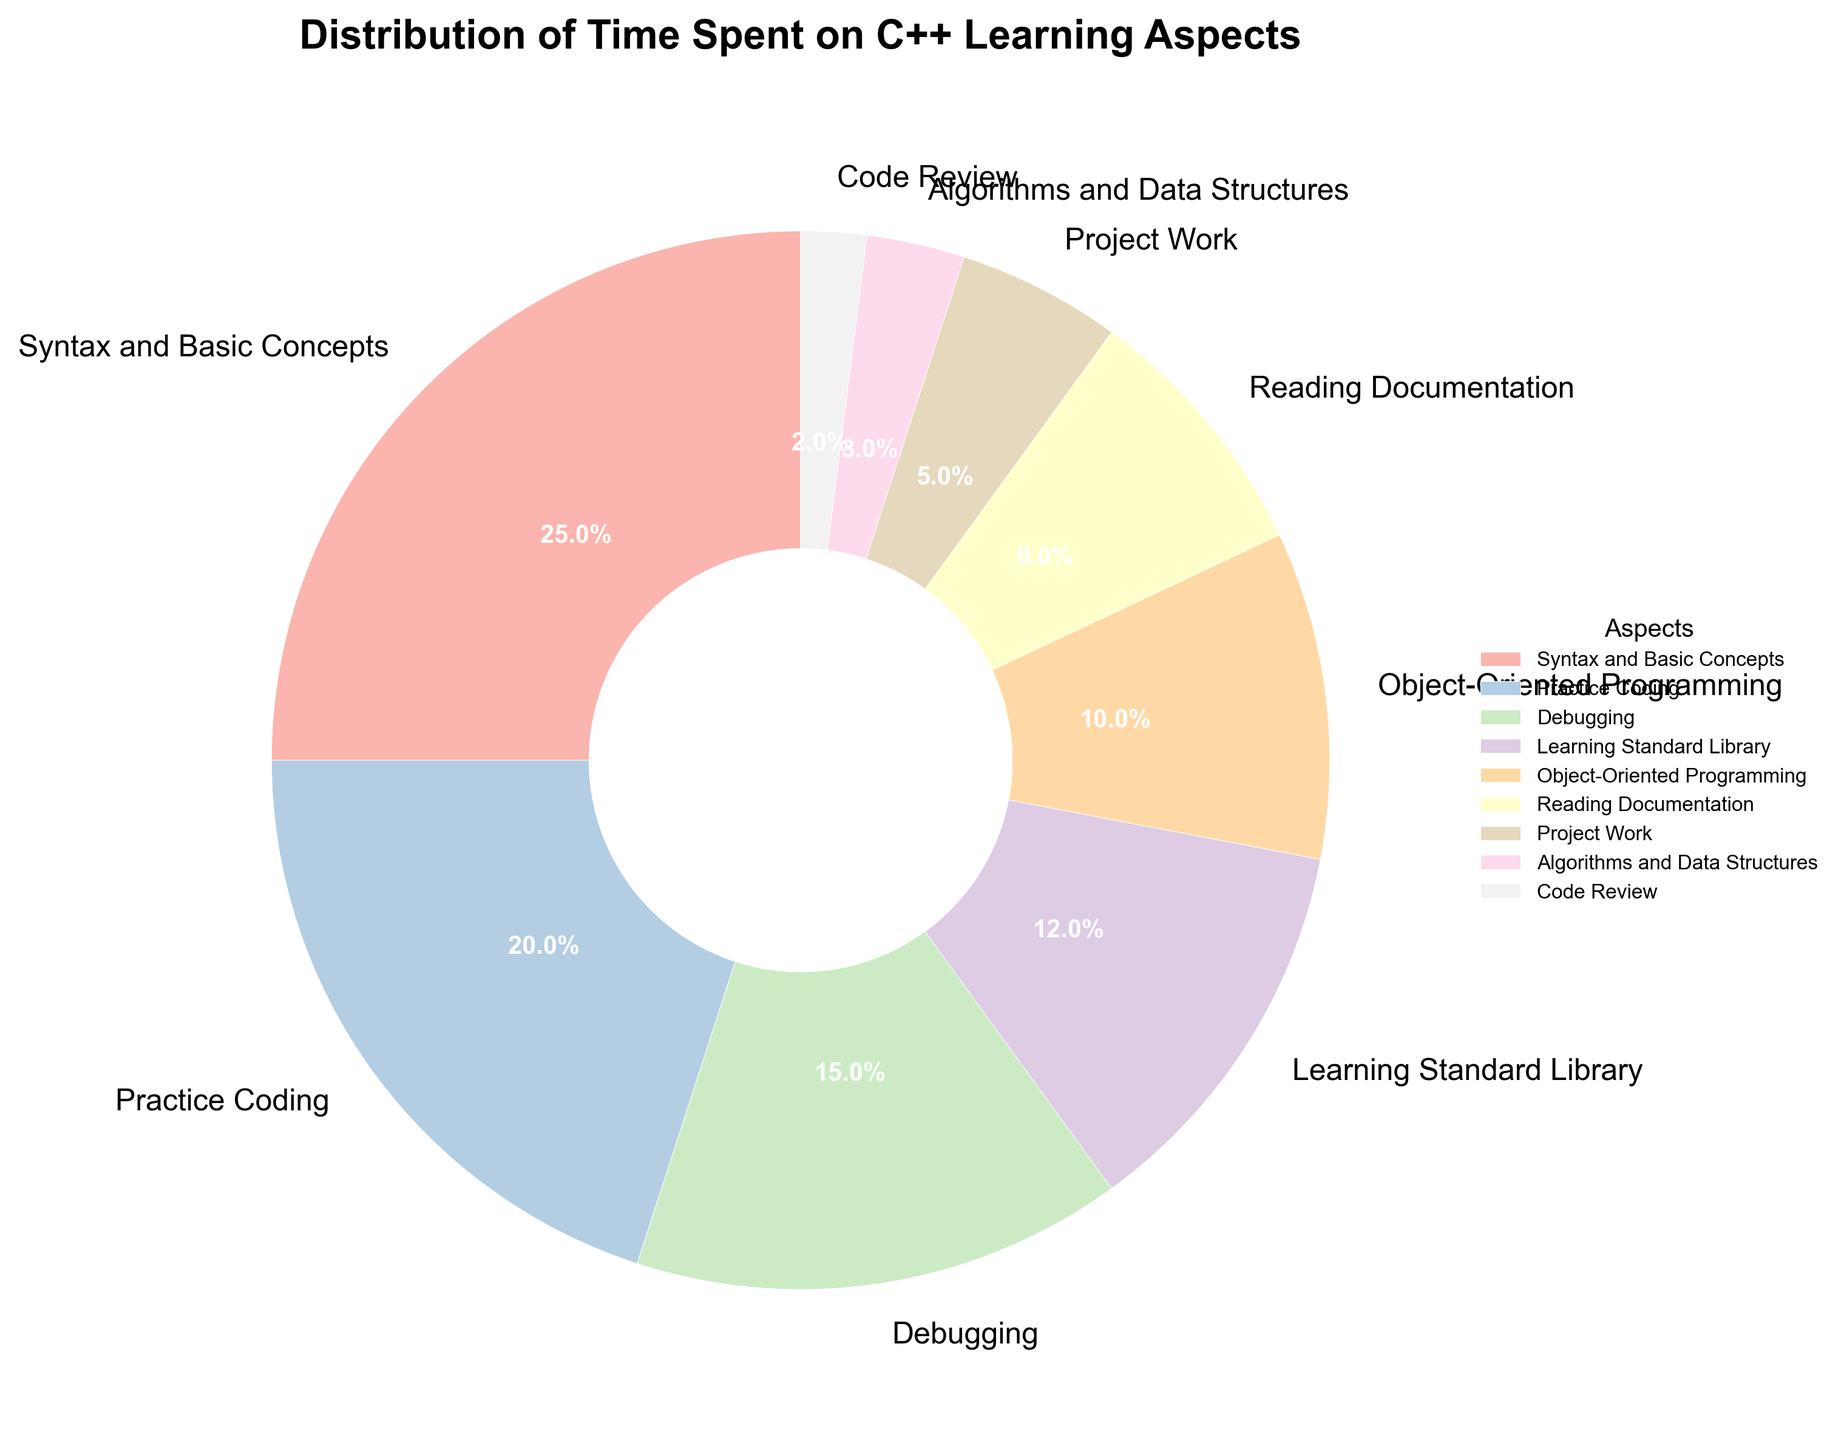What is the aspect with the highest percentage? The figure shows the percentages for each aspect of C++ learning. The highest percentage is seen in "Syntax and Basic Concepts" with 25%.
Answer: Syntax and Basic Concepts Which aspect has the lowest percentage? By examining the figure, the aspect with the lowest percentage is "Code Review" at 2%.
Answer: Code Review How much more time is spent on "Practice Coding" than on "Project Work"? "Practice Coding" is 20%, and "Project Work" is 5%. The difference is 20% - 5% = 15%.
Answer: 15% What is the combined percentage of time spent on "Debugging", "Learning Standard Library", and "Reading Documentation"? Add the percentages for "Debugging" (15%), "Learning Standard Library" (12%), and "Reading Documentation" (8%). 15% + 12% + 8% = 35%.
Answer: 35% Which aspect is represented with a color close to blue? The figure uses different colors for each segment. One of the segments is shaded in a color close to blue, which represents "Learning Standard Library".
Answer: Learning Standard Library Is more time spent on "Object-Oriented Programming" or "Algorithms and Data Structures"? "Object-Oriented Programming" has 10%, while "Algorithms and Data Structures" has 3%. Since 10% > 3%, more time is spent on "Object-Oriented Programming".
Answer: Object-Oriented Programming Which two aspects together cover a fifth of the total time? A fifth of 100% is 20%. "Algorithm and Data Structures" (3%) and "Project Work" (5%) together cover 8%, while "Project Work" (5%) and "Reading Documentation" (8%) together cover 13%. However, "Debugging" (15%) and "Code Review" (2%) together cover 17%. Therefore, the two aspects "Debugging" and "Practice Coding" together cover 15% + 20% = 35%.
Answer: Debugging and Project Work What aspect represents a portion slightly larger than 10%? The aspect "Object-Oriented Programming" is slightly larger than 10% at exactly 10%. Therefore, it covers a portion slightly larger than 10%.
Answer: Object-Oriented Programming 